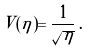Convert formula to latex. <formula><loc_0><loc_0><loc_500><loc_500>V ( \eta ) = \frac { 1 } { \sqrt { \eta } } \, .</formula> 